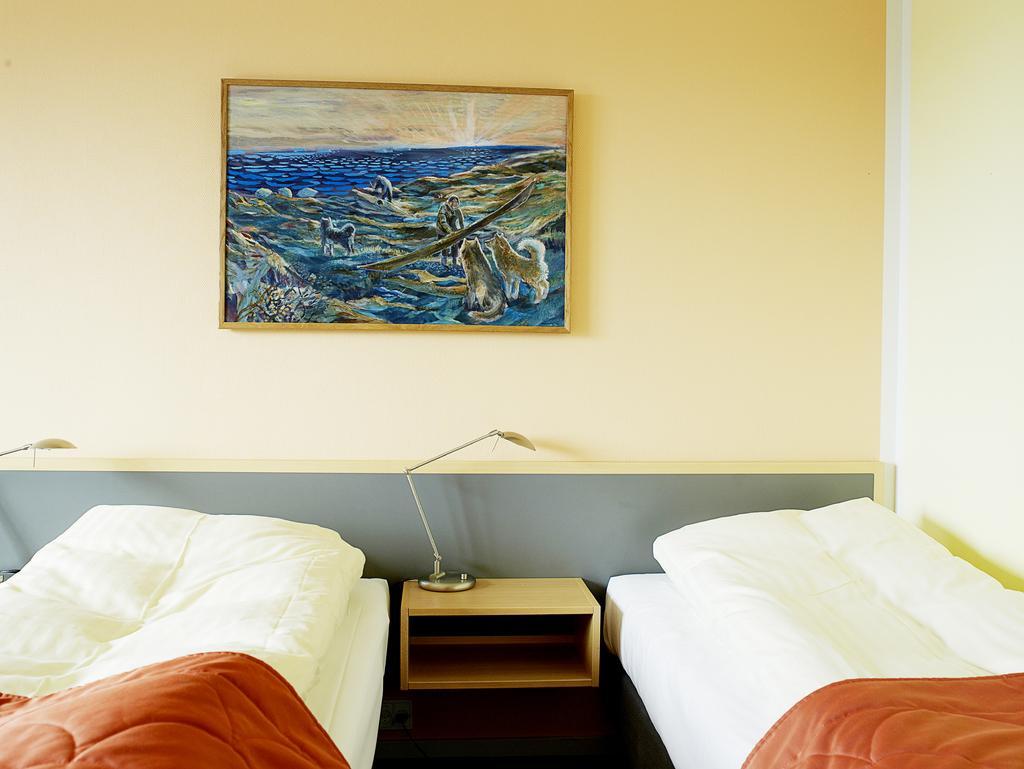Could you give a brief overview of what you see in this image? There are two beds in the image and at the middle of the image there is a painting which is attached to the wall. 